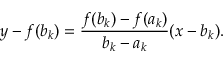Convert formula to latex. <formula><loc_0><loc_0><loc_500><loc_500>y - f ( b _ { k } ) = { \frac { f ( b _ { k } ) - f ( a _ { k } ) } { b _ { k } - a _ { k } } } ( x - b _ { k } ) .</formula> 